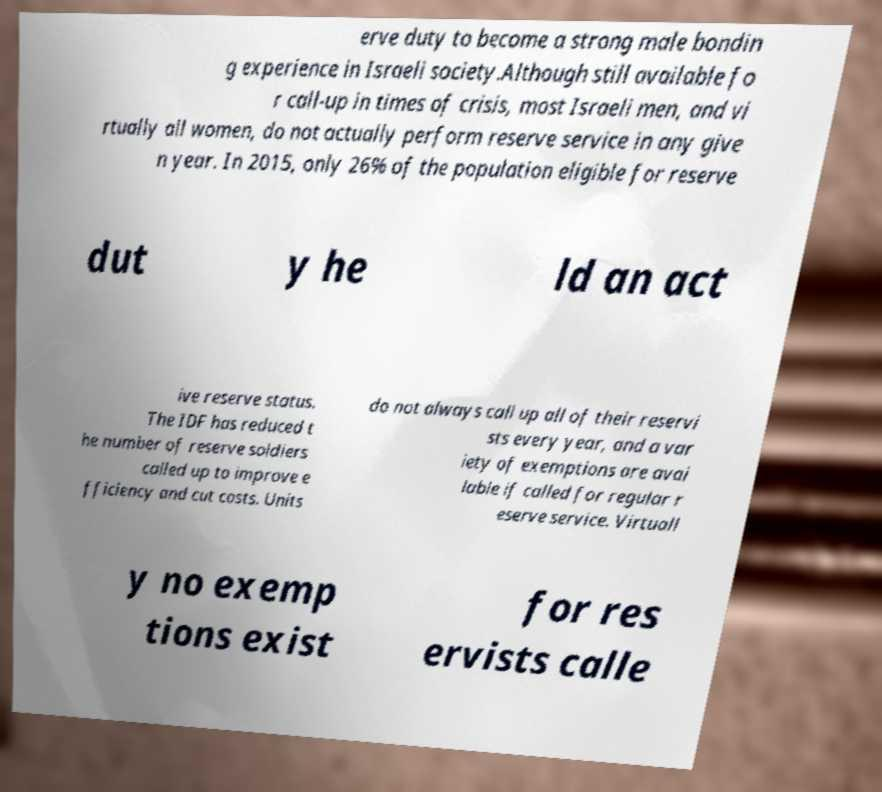I need the written content from this picture converted into text. Can you do that? erve duty to become a strong male bondin g experience in Israeli society.Although still available fo r call-up in times of crisis, most Israeli men, and vi rtually all women, do not actually perform reserve service in any give n year. In 2015, only 26% of the population eligible for reserve dut y he ld an act ive reserve status. The IDF has reduced t he number of reserve soldiers called up to improve e fficiency and cut costs. Units do not always call up all of their reservi sts every year, and a var iety of exemptions are avai lable if called for regular r eserve service. Virtuall y no exemp tions exist for res ervists calle 